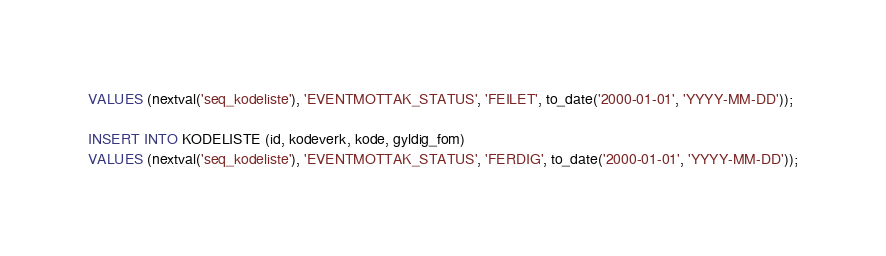<code> <loc_0><loc_0><loc_500><loc_500><_SQL_>VALUES (nextval('seq_kodeliste'), 'EVENTMOTTAK_STATUS', 'FEILET', to_date('2000-01-01', 'YYYY-MM-DD'));

INSERT INTO KODELISTE (id, kodeverk, kode, gyldig_fom)
VALUES (nextval('seq_kodeliste'), 'EVENTMOTTAK_STATUS', 'FERDIG', to_date('2000-01-01', 'YYYY-MM-DD'));
</code> 